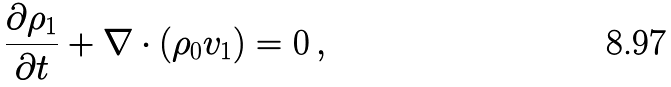<formula> <loc_0><loc_0><loc_500><loc_500>\frac { \partial \rho _ { 1 } } { \partial t } + \nabla \cdot \left ( \rho _ { 0 } v _ { 1 } \right ) = 0 \, ,</formula> 